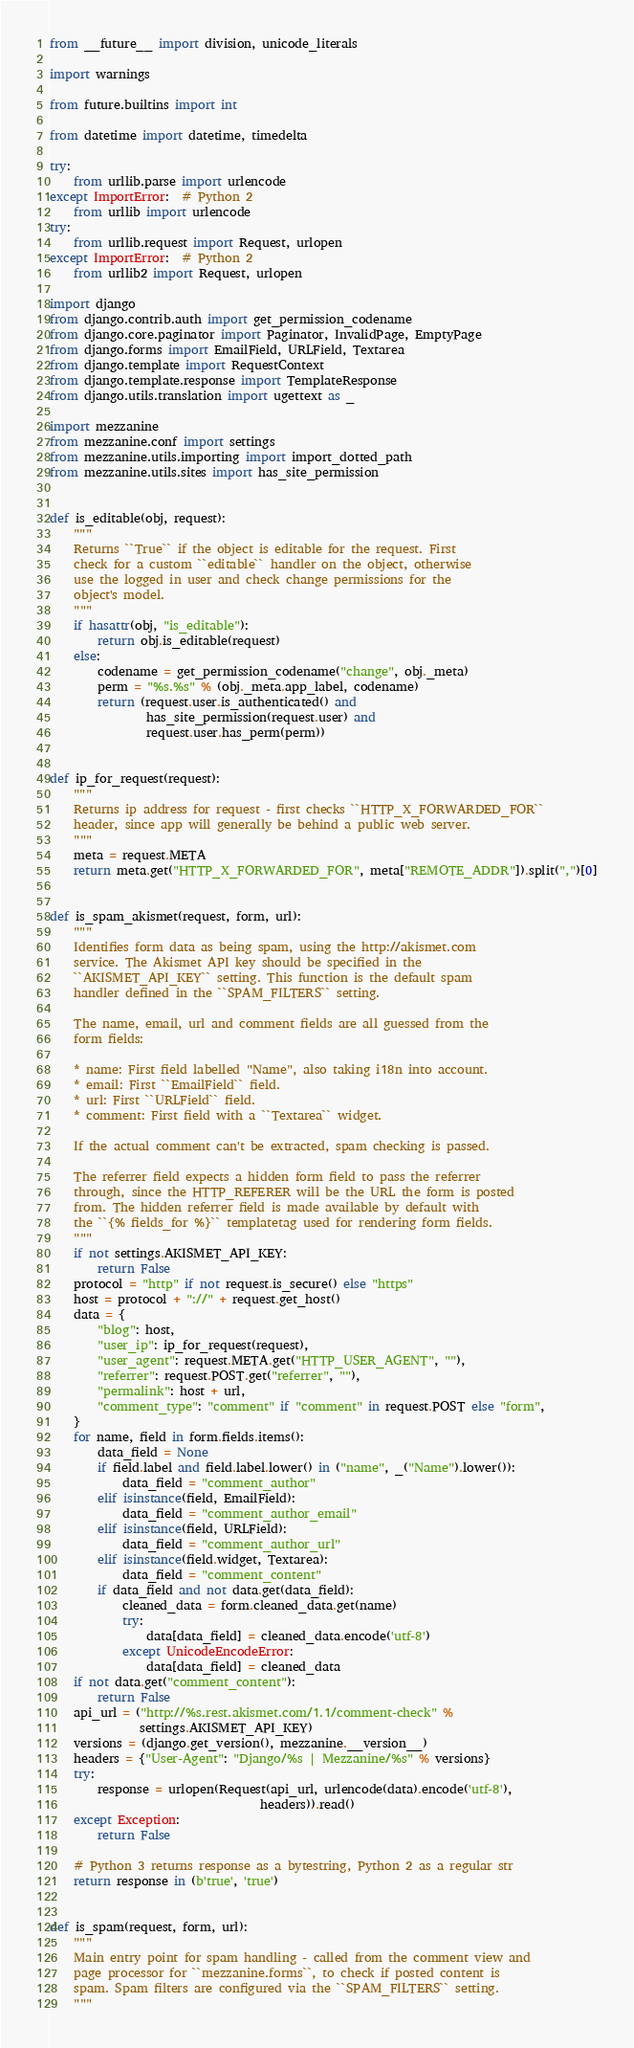Convert code to text. <code><loc_0><loc_0><loc_500><loc_500><_Python_>from __future__ import division, unicode_literals

import warnings

from future.builtins import int

from datetime import datetime, timedelta

try:
    from urllib.parse import urlencode
except ImportError:  # Python 2
    from urllib import urlencode
try:
    from urllib.request import Request, urlopen
except ImportError:  # Python 2
    from urllib2 import Request, urlopen

import django
from django.contrib.auth import get_permission_codename
from django.core.paginator import Paginator, InvalidPage, EmptyPage
from django.forms import EmailField, URLField, Textarea
from django.template import RequestContext
from django.template.response import TemplateResponse
from django.utils.translation import ugettext as _

import mezzanine
from mezzanine.conf import settings
from mezzanine.utils.importing import import_dotted_path
from mezzanine.utils.sites import has_site_permission


def is_editable(obj, request):
    """
    Returns ``True`` if the object is editable for the request. First
    check for a custom ``editable`` handler on the object, otherwise
    use the logged in user and check change permissions for the
    object's model.
    """
    if hasattr(obj, "is_editable"):
        return obj.is_editable(request)
    else:
        codename = get_permission_codename("change", obj._meta)
        perm = "%s.%s" % (obj._meta.app_label, codename)
        return (request.user.is_authenticated() and
                has_site_permission(request.user) and
                request.user.has_perm(perm))


def ip_for_request(request):
    """
    Returns ip address for request - first checks ``HTTP_X_FORWARDED_FOR``
    header, since app will generally be behind a public web server.
    """
    meta = request.META
    return meta.get("HTTP_X_FORWARDED_FOR", meta["REMOTE_ADDR"]).split(",")[0]


def is_spam_akismet(request, form, url):
    """
    Identifies form data as being spam, using the http://akismet.com
    service. The Akismet API key should be specified in the
    ``AKISMET_API_KEY`` setting. This function is the default spam
    handler defined in the ``SPAM_FILTERS`` setting.

    The name, email, url and comment fields are all guessed from the
    form fields:

    * name: First field labelled "Name", also taking i18n into account.
    * email: First ``EmailField`` field.
    * url: First ``URLField`` field.
    * comment: First field with a ``Textarea`` widget.

    If the actual comment can't be extracted, spam checking is passed.

    The referrer field expects a hidden form field to pass the referrer
    through, since the HTTP_REFERER will be the URL the form is posted
    from. The hidden referrer field is made available by default with
    the ``{% fields_for %}`` templatetag used for rendering form fields.
    """
    if not settings.AKISMET_API_KEY:
        return False
    protocol = "http" if not request.is_secure() else "https"
    host = protocol + "://" + request.get_host()
    data = {
        "blog": host,
        "user_ip": ip_for_request(request),
        "user_agent": request.META.get("HTTP_USER_AGENT", ""),
        "referrer": request.POST.get("referrer", ""),
        "permalink": host + url,
        "comment_type": "comment" if "comment" in request.POST else "form",
    }
    for name, field in form.fields.items():
        data_field = None
        if field.label and field.label.lower() in ("name", _("Name").lower()):
            data_field = "comment_author"
        elif isinstance(field, EmailField):
            data_field = "comment_author_email"
        elif isinstance(field, URLField):
            data_field = "comment_author_url"
        elif isinstance(field.widget, Textarea):
            data_field = "comment_content"
        if data_field and not data.get(data_field):
            cleaned_data = form.cleaned_data.get(name)
            try:
                data[data_field] = cleaned_data.encode('utf-8')
            except UnicodeEncodeError:
                data[data_field] = cleaned_data
    if not data.get("comment_content"):
        return False
    api_url = ("http://%s.rest.akismet.com/1.1/comment-check" %
               settings.AKISMET_API_KEY)
    versions = (django.get_version(), mezzanine.__version__)
    headers = {"User-Agent": "Django/%s | Mezzanine/%s" % versions}
    try:
        response = urlopen(Request(api_url, urlencode(data).encode('utf-8'),
                                   headers)).read()
    except Exception:
        return False

    # Python 3 returns response as a bytestring, Python 2 as a regular str
    return response in (b'true', 'true')


def is_spam(request, form, url):
    """
    Main entry point for spam handling - called from the comment view and
    page processor for ``mezzanine.forms``, to check if posted content is
    spam. Spam filters are configured via the ``SPAM_FILTERS`` setting.
    """</code> 